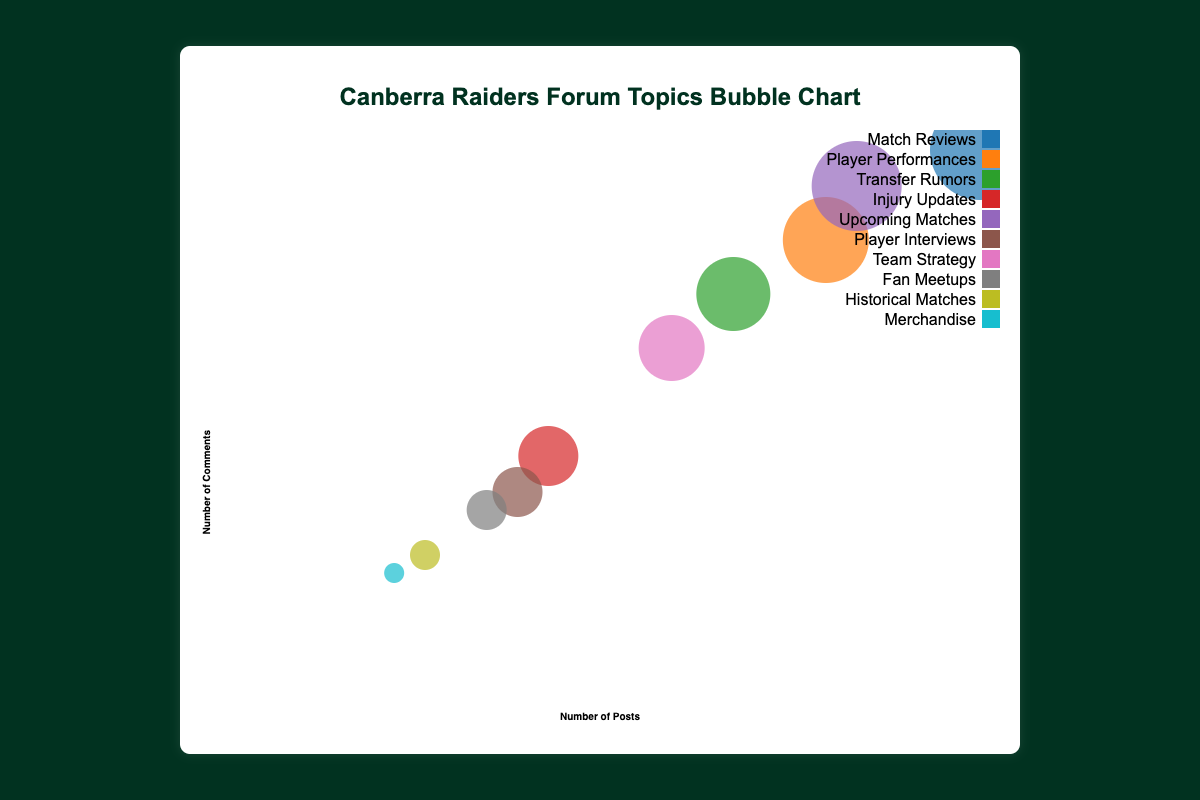What is the title of the chart? The title of the chart is prominently displayed at the top of the figure. Reading it directly from the figure, we find that the title is 'Canberra Raiders Forum Topics Bubble Chart'.
Answer: Canberra Raiders Forum Topics Bubble Chart What do the x-axis and y-axis represent? The x-axis represents the "Number of Posts", and the y-axis represents the "Number of Comments". Both axis titles are labeled clearly at the bottom and side of the graph.
Answer: Number of Posts, Number of Comments How many topics are represented in the bubble chart? By counting the bubbles, we can determine the number of distinct topics presented in the chart. There are 10 bubbles, meaning there are 10 topics represented.
Answer: 10 Which topic has the highest number of posts? Observing the x-axis and finding the bubble farthest to the right gives us the topic with the highest number of posts. The "Match Reviews" topic bubble is positioned farthest to the right with 120 posts.
Answer: Match Reviews Which topic has the smallest popularity score? By looking at the sizes of the bubbles, the smallest one corresponds to the lowest popularity score. "Merchandise" has the smallest bubble with a popularity score of 45.
Answer: Merchandise Which topic received the most comments? Observing the y-axis and finding the bubble highest on the graph gives us the topic with the most comments. The "Match Reviews" topic bubble is positioned highest with 300 comments.
Answer: Match Reviews Which two topics have the closest number of posts? By comparing the x-axis positions, "Transfer Rumors" with 80 posts and "Team Strategy" with 70 posts are closest to each other.
Answer: Transfer Rumors and Team Strategy What is the total number of comments for "Player Performances" and "Upcoming Matches"? Add the number of comments for both topics. Player Performances has 250 comments and Upcoming Matches has 280 comments. The sum is 250 + 280 = 530.
Answer: 530 How does the popularity score of "Player Interviews" compare with the popularity score of "Fan Meetups"? The bubbles of Player Interviews and Fan Meetups can be compared by size. Player Interviews have a score of 60, and Fan Meetups have a score of 55, making Player Interviews' score slightly higher.
Answer: Player Interviews has a higher popularity score Does the topic with the least number of comments also have the lowest popularity score? First, identify the topic with the least comments by looking at the y-axis (leftmost bubble). "Merchandise" has the least number of comments (65). This same topic also has the lowest popularity score.
Answer: Yes 